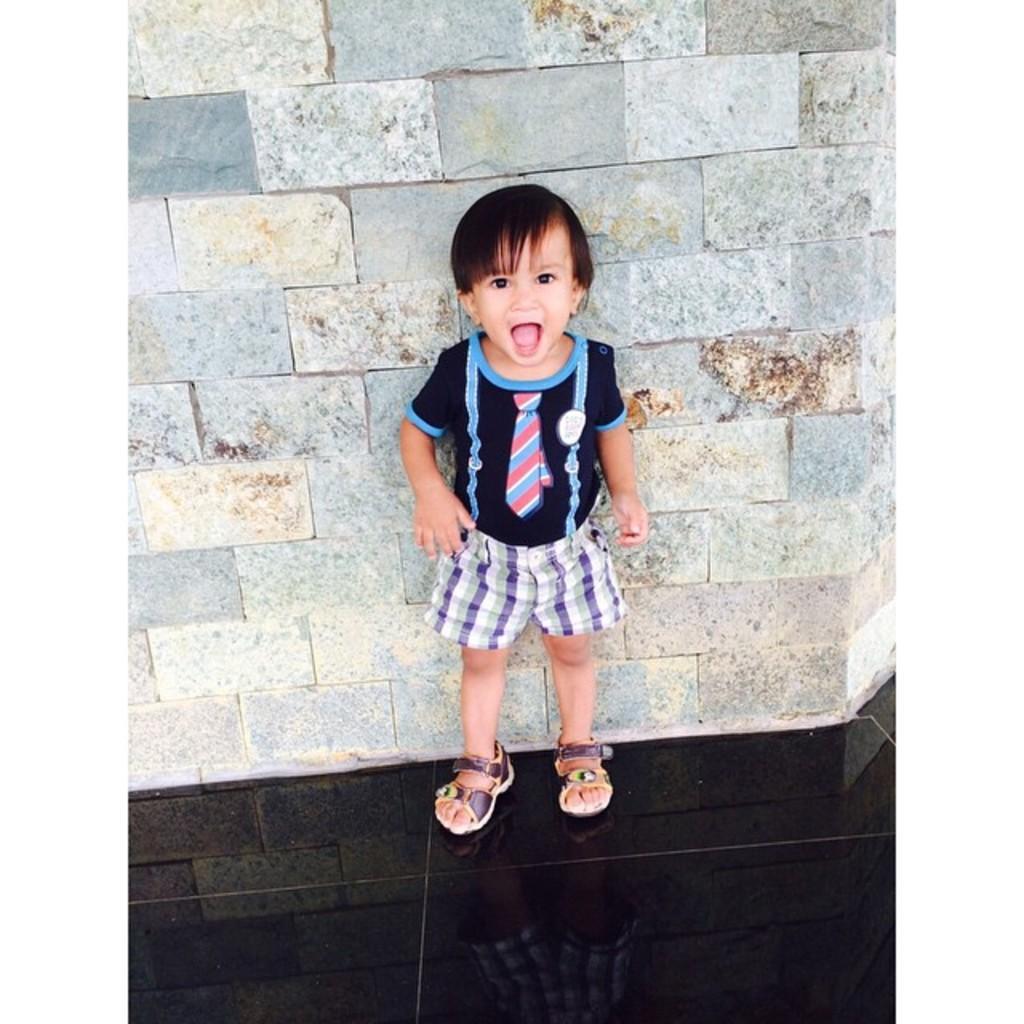Describe this image in one or two sentences. In this image I can see a person standing and the person is wearing black, blue and purple color dress. Background the wall is in gray and brown color. 